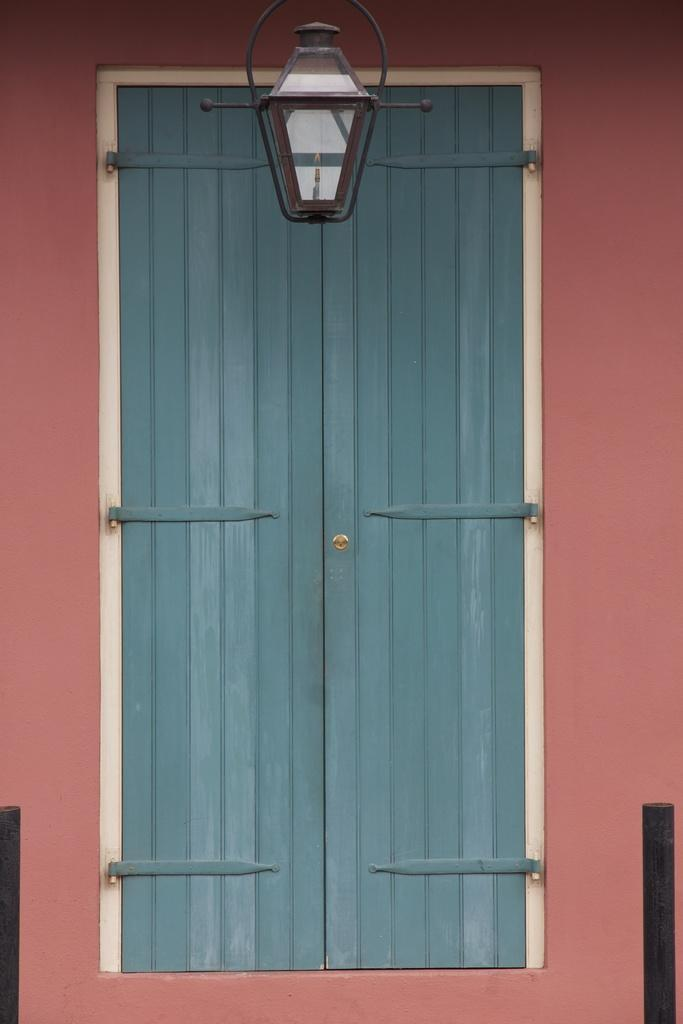What is present on the wall in the image? There is a door on the wall in the image. Can you describe the door in the image? The door has lighting on the top of it. What might be the purpose of the lighting on the door? The lighting on the door could provide illumination or serve as a decorative element. Is there a sweater being worn by anyone in the image? There is no information about a sweater or any clothing in the image. 